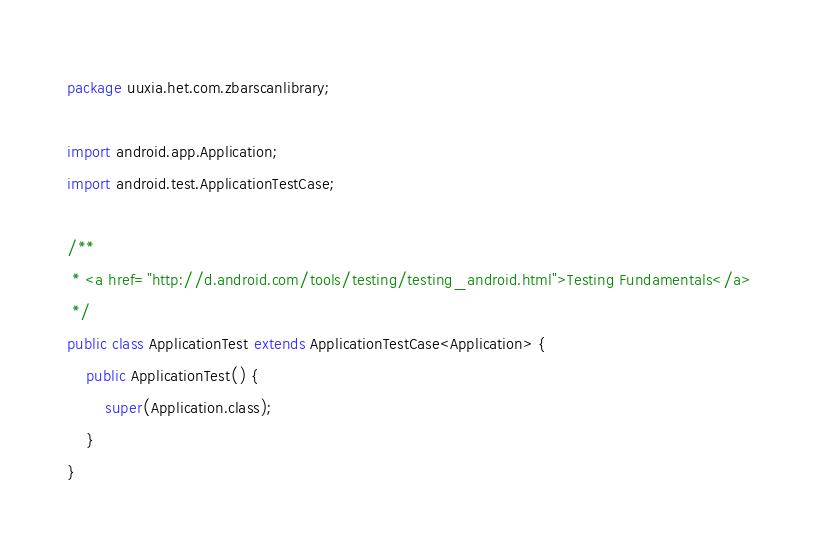<code> <loc_0><loc_0><loc_500><loc_500><_Java_>package uuxia.het.com.zbarscanlibrary;

import android.app.Application;
import android.test.ApplicationTestCase;

/**
 * <a href="http://d.android.com/tools/testing/testing_android.html">Testing Fundamentals</a>
 */
public class ApplicationTest extends ApplicationTestCase<Application> {
    public ApplicationTest() {
        super(Application.class);
    }
}</code> 